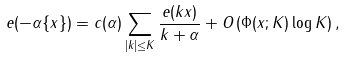<formula> <loc_0><loc_0><loc_500><loc_500>e ( - \alpha \{ x \} ) = c ( \alpha ) \sum _ { | k | \leq K } \frac { e ( k x ) } { k + \alpha } + O \left ( \Phi ( x ; K ) \log K \right ) ,</formula> 